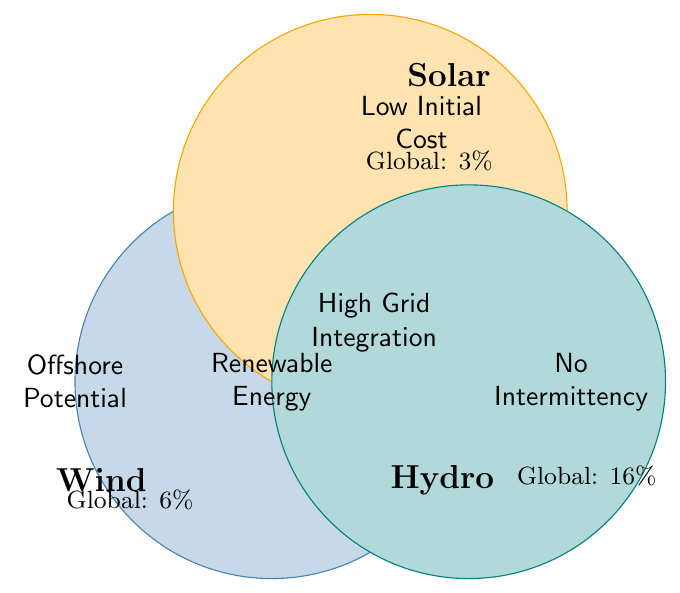What are the renewable energy categories shown in the figure? The figure shows three renewable energy categories labeled in each circle, which are Wind, Solar, and Hydro.
Answer: Wind, Solar, Hydro Which energy source has the highest global adoption rate? The global adoption rates are labeled near each circle showing 6% for Wind, 3% for Solar, and 16% for Hydro. Hydro has the highest global adoption rate.
Answer: Hydro What characteristic is common to all three renewable energy sources? The figure shows "High Grid Integration" in the overlapping area between Wind, Solar, and Hydro.
Answer: High Grid Integration Which energy type has offshore potential? The label "Offshore Potential" is placed inside the Wind circle only.
Answer: Wind Compare the initial costs of wind and hydroelectric energy sources. The initial cost for Wind is labeled as "High", whereas for Hydro it is labeled as "Very High". Wind has lower initial costs compared to Hydro.
Answer: Wind Which renewable energy source does not have intermittency? The "No Intermittency" label is placed inside the Hydro circle only, indicating it does not have intermittency.
Answer: Hydro What is the area of overlap between Wind and Solar? The center overlapping label reads "High Grid Integration" for the areas shared by Wind, Solar, and Hydro, but Solar and Wind also share grid integration within the larger context of renewable energy.
Answer: High Grid Integration Is the environmental impact of solar energy lower than that of hydroelectric energy? The environmental impacts are labeled as "Very Low" for Solar and "Medium" for Hydro. Solar has a lower environmental impact than Hydro.
Answer: Yes Which renewable energy source uses the most land? The land use for Hydro is labeled as "Very High" compared to "Medium" for Wind and "High" for Solar.
Answer: Hydro 